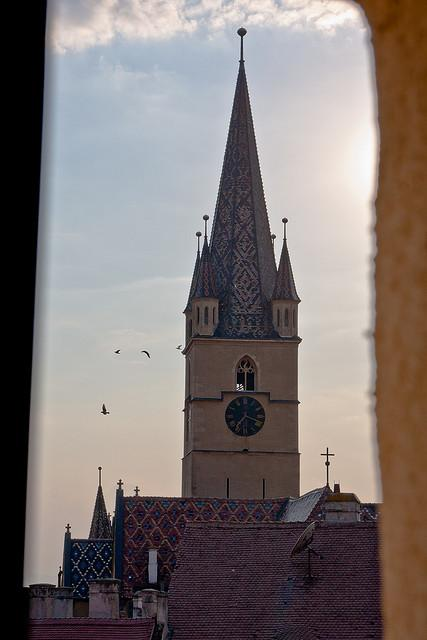How many towers are on the top of the clock tower with a black clock face? Please explain your reasoning. five. There are 5. 